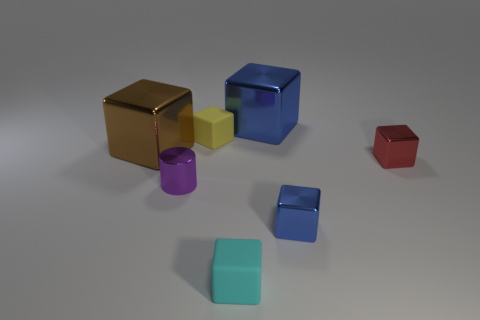Subtract all blue blocks. How many blocks are left? 4 Subtract all small cyan blocks. How many blocks are left? 5 Subtract all red cubes. Subtract all cyan spheres. How many cubes are left? 5 Add 2 cyan rubber things. How many objects exist? 9 Subtract all cylinders. How many objects are left? 6 Subtract 0 blue cylinders. How many objects are left? 7 Subtract all small blocks. Subtract all matte cubes. How many objects are left? 1 Add 1 small cubes. How many small cubes are left? 5 Add 1 blue objects. How many blue objects exist? 3 